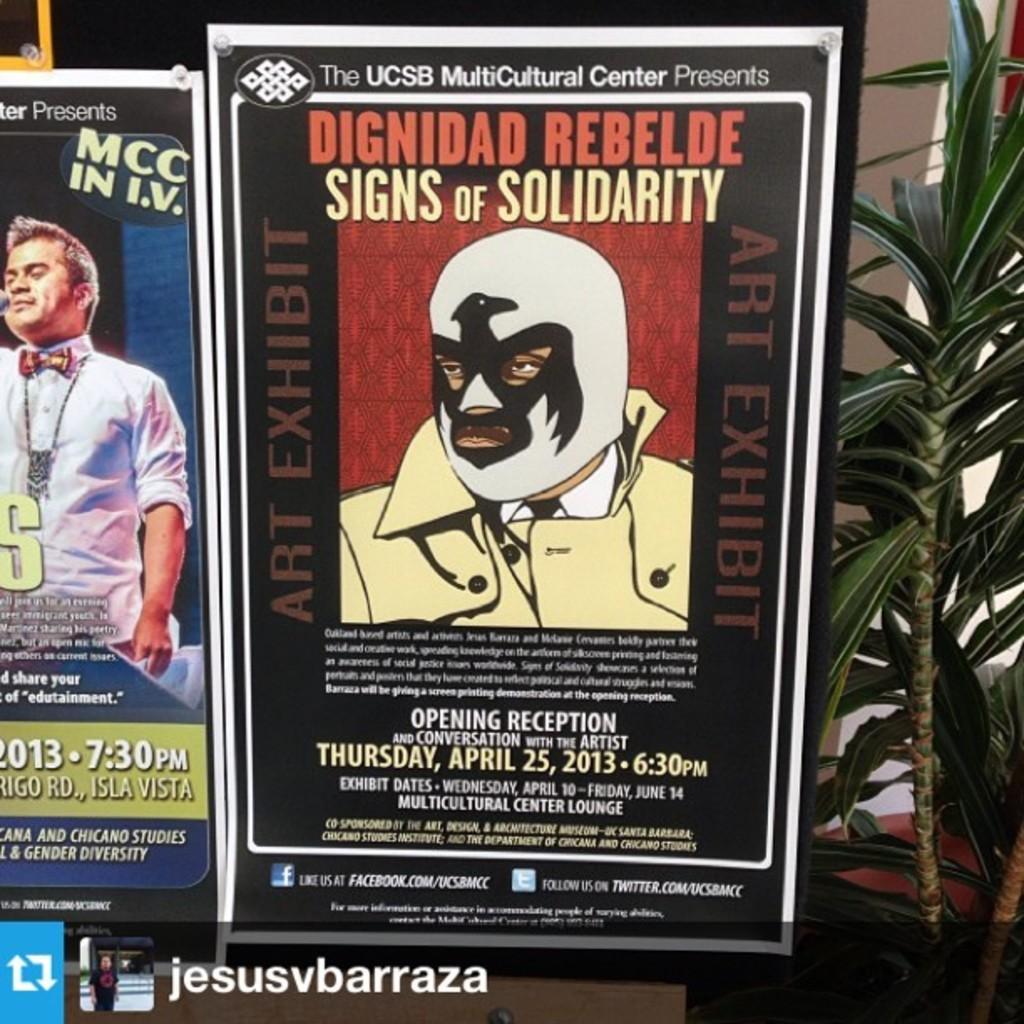Can you describe this image briefly? In the picture we can see two posts to the board and beside it, we can see a part of the plant. 